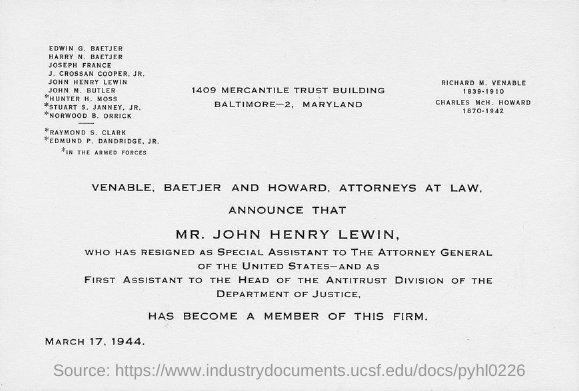Outline some significant characteristics in this image. March 17, 1944 is the date. 